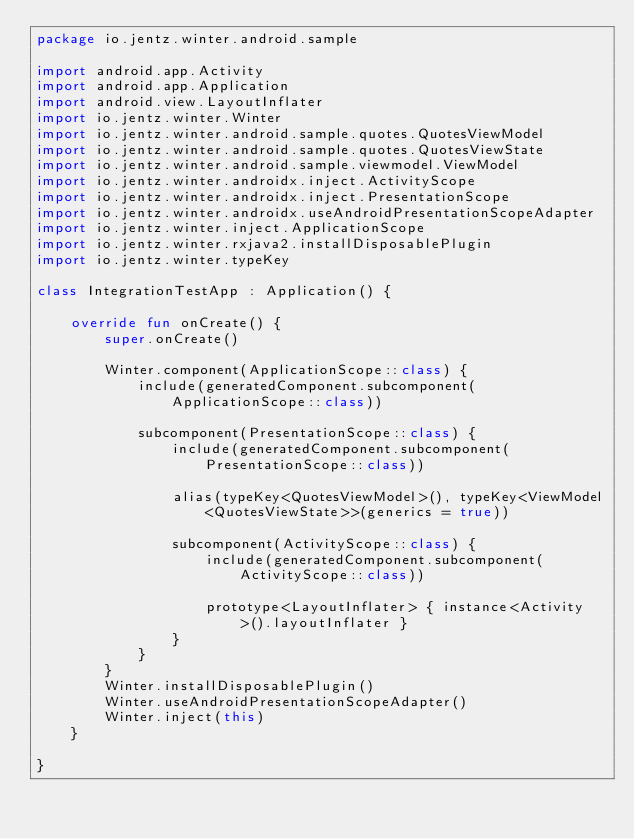<code> <loc_0><loc_0><loc_500><loc_500><_Kotlin_>package io.jentz.winter.android.sample

import android.app.Activity
import android.app.Application
import android.view.LayoutInflater
import io.jentz.winter.Winter
import io.jentz.winter.android.sample.quotes.QuotesViewModel
import io.jentz.winter.android.sample.quotes.QuotesViewState
import io.jentz.winter.android.sample.viewmodel.ViewModel
import io.jentz.winter.androidx.inject.ActivityScope
import io.jentz.winter.androidx.inject.PresentationScope
import io.jentz.winter.androidx.useAndroidPresentationScopeAdapter
import io.jentz.winter.inject.ApplicationScope
import io.jentz.winter.rxjava2.installDisposablePlugin
import io.jentz.winter.typeKey

class IntegrationTestApp : Application() {

    override fun onCreate() {
        super.onCreate()

        Winter.component(ApplicationScope::class) {
            include(generatedComponent.subcomponent(ApplicationScope::class))

            subcomponent(PresentationScope::class) {
                include(generatedComponent.subcomponent(PresentationScope::class))

                alias(typeKey<QuotesViewModel>(), typeKey<ViewModel<QuotesViewState>>(generics = true))

                subcomponent(ActivityScope::class) {
                    include(generatedComponent.subcomponent(ActivityScope::class))
                    
                    prototype<LayoutInflater> { instance<Activity>().layoutInflater }
                }
            }
        }
        Winter.installDisposablePlugin()
        Winter.useAndroidPresentationScopeAdapter()
        Winter.inject(this)
    }

}</code> 